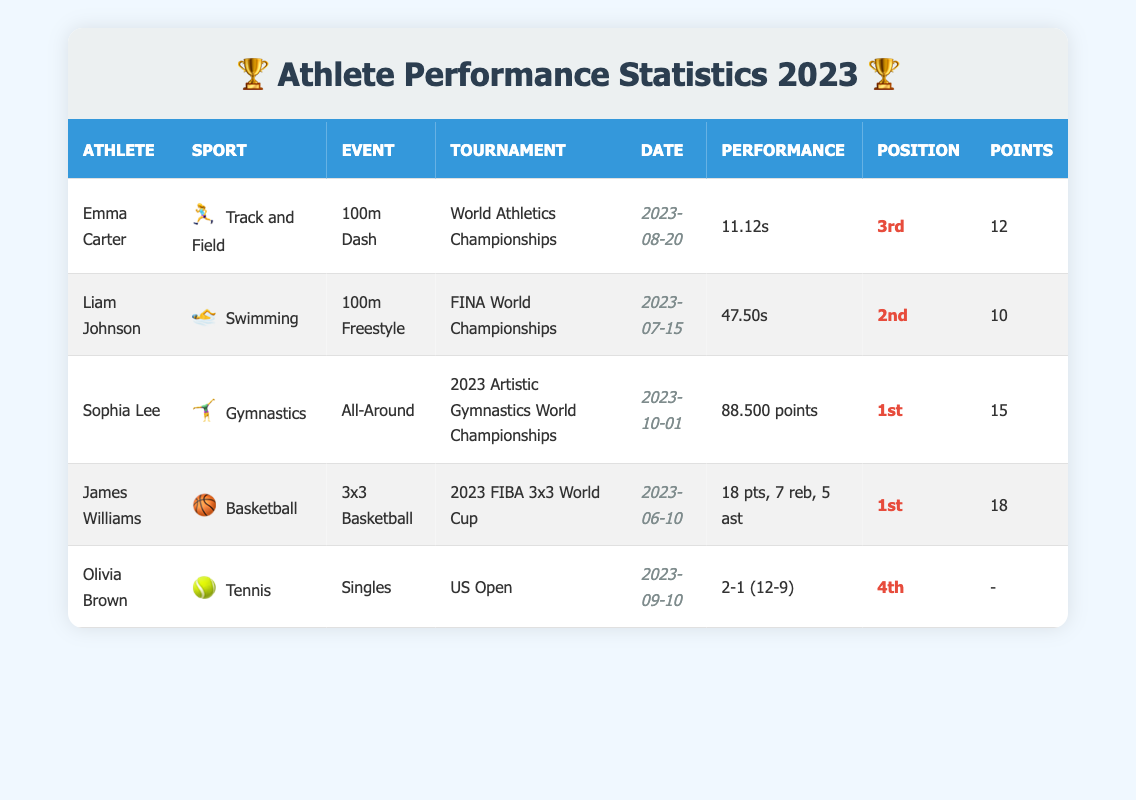What is the date of Emma Carter's performance? Emma Carter's performance is listed in the table under the "Date" column with the entry "2023-08-20." This indicates the date on which she competed in the 100m Dash at the World Athletics Championships.
Answer: 2023-08-20 Who won the gymnastics all-around event? Sophia Lee is identified in the table as competing in the gymnastics all-around event and is noted as finishing in the "1st" position, which indicates that she was the winner of this event.
Answer: Sophia Lee How many points did James Williams score in the 3x3 Basketball event? The table shows that James Williams scored "18" points in the 3x3 Basketball event, making it straightforward to answer the question.
Answer: 18 Which athlete had the highest score in their event based on points scored? The entries indicate that Sophia Lee scored "15" points, while the next highest was James Williams with "18" points. Since James scored higher, he had the highest score overall in the context of points scored.
Answer: James Williams What is the difference in performance points between the highest and lowest scoring athletes? The highest score is from James Williams with "18" points, while Olivia Brown scored "-", meaning no points were recorded. To find the difference, we consider 18 - 0 (using 0 for Olivia since no points are given), resulting in 18 as the difference.
Answer: 18 Did any athlete participate in multiple events in 2023? Reviewing the table, each athlete is listed with a unique event and tournament. No athlete appears to compete in more than one event; therefore, the answer is based on individual performances.
Answer: No What is the average position among the athletes listed? The positions of the athletes are: 3, 2, 1, 1, and 4. By calculating the average, we sum the positions (3 + 2 + 1 + 1 + 4 = 11) and divide by the number of athletes (5), resulting in an average position of 2.2.
Answer: 2.2 Which sport had the highest-ranked athlete? Looking at the table, "Gymnastics" has Sophia Lee in "1st" position, which is the highest ranking across all sports listed. Other sports have lower rankings.
Answer: Gymnastics What was Olivia Brown's game record in the US Open? In the table, Olivia Brown's record in the US Open is displayed as "2-1 (12-9)," indicating she won 2 sets and lost 1 set. This is directly taken from her entry.
Answer: 2-1 